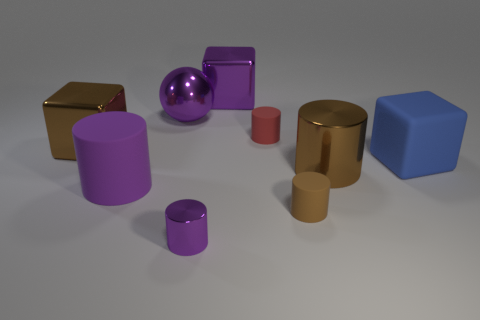Is there any other thing that is made of the same material as the big brown block?
Provide a short and direct response. Yes. Does the metal block to the right of the big brown cube have the same size as the brown metal object that is on the right side of the brown block?
Provide a short and direct response. Yes. What number of tiny objects are spheres or red cylinders?
Provide a succinct answer. 1. What number of large cubes are both in front of the purple metal block and right of the large shiny ball?
Keep it short and to the point. 1. Does the brown block have the same material as the big cylinder behind the purple rubber cylinder?
Give a very brief answer. Yes. How many purple things are metal things or rubber balls?
Your response must be concise. 3. Is there a green rubber cylinder that has the same size as the red cylinder?
Your answer should be very brief. No. What material is the brown cylinder in front of the matte cylinder that is to the left of the metal cylinder on the left side of the brown matte object?
Keep it short and to the point. Rubber. Are there the same number of tiny matte things that are to the right of the tiny brown cylinder and red rubber cylinders?
Ensure brevity in your answer.  No. Are the cylinder behind the large brown metal cylinder and the block to the left of the purple rubber thing made of the same material?
Ensure brevity in your answer.  No. 